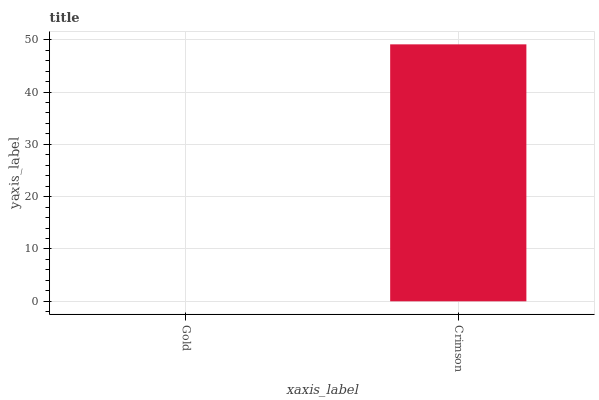Is Gold the minimum?
Answer yes or no. Yes. Is Crimson the maximum?
Answer yes or no. Yes. Is Crimson the minimum?
Answer yes or no. No. Is Crimson greater than Gold?
Answer yes or no. Yes. Is Gold less than Crimson?
Answer yes or no. Yes. Is Gold greater than Crimson?
Answer yes or no. No. Is Crimson less than Gold?
Answer yes or no. No. Is Crimson the high median?
Answer yes or no. Yes. Is Gold the low median?
Answer yes or no. Yes. Is Gold the high median?
Answer yes or no. No. Is Crimson the low median?
Answer yes or no. No. 